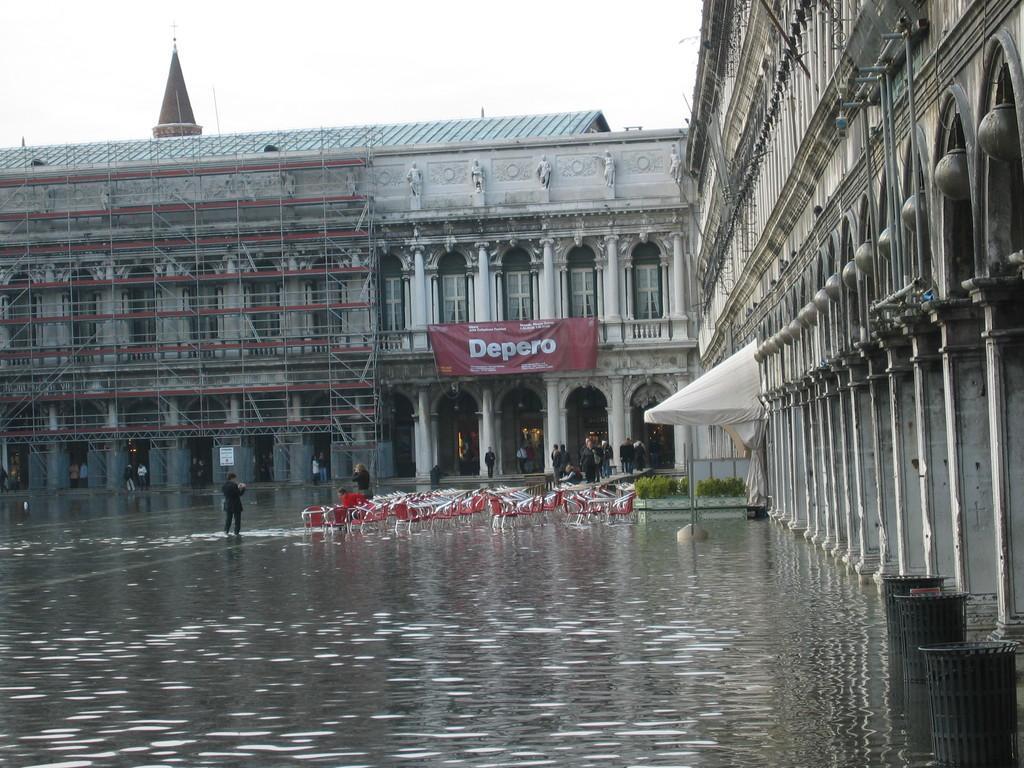Please provide a concise description of this image. This is an outside view. At the bottom, I can see the water on the ground. In the middle of the image there are empty chairs placed on the ground and few people are standing. On the right side there is a building along with the pillars. In the background there is another building and a banner is attached to this building. On the banner, I can see some text. At the top of the image I can see the sky. In the bottom right there are three dustbins. 